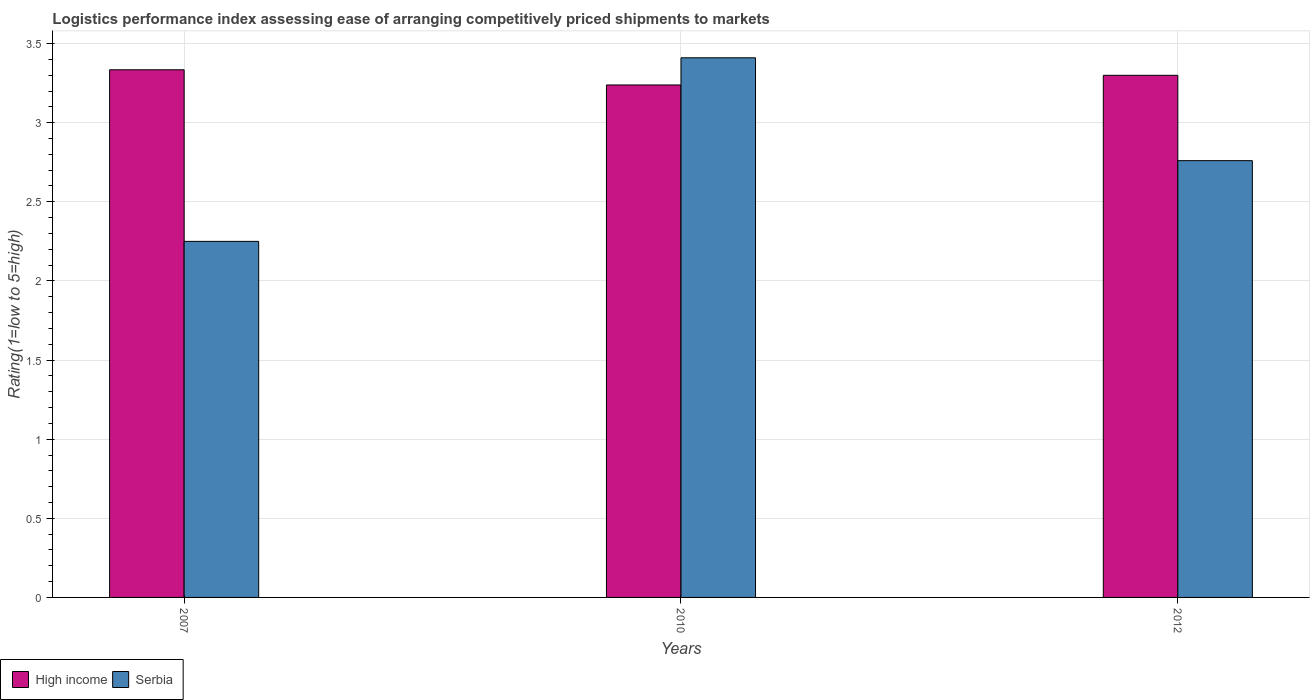How many different coloured bars are there?
Your response must be concise. 2. How many groups of bars are there?
Offer a terse response. 3. Are the number of bars on each tick of the X-axis equal?
Provide a short and direct response. Yes. What is the label of the 2nd group of bars from the left?
Your response must be concise. 2010. In how many cases, is the number of bars for a given year not equal to the number of legend labels?
Provide a short and direct response. 0. What is the Logistic performance index in Serbia in 2012?
Keep it short and to the point. 2.76. Across all years, what is the maximum Logistic performance index in Serbia?
Provide a succinct answer. 3.41. Across all years, what is the minimum Logistic performance index in High income?
Ensure brevity in your answer.  3.24. In which year was the Logistic performance index in High income maximum?
Your answer should be very brief. 2007. What is the total Logistic performance index in Serbia in the graph?
Ensure brevity in your answer.  8.42. What is the difference between the Logistic performance index in Serbia in 2007 and that in 2012?
Give a very brief answer. -0.51. What is the difference between the Logistic performance index in Serbia in 2007 and the Logistic performance index in High income in 2010?
Make the answer very short. -0.99. What is the average Logistic performance index in High income per year?
Provide a succinct answer. 3.29. In the year 2012, what is the difference between the Logistic performance index in Serbia and Logistic performance index in High income?
Provide a succinct answer. -0.54. In how many years, is the Logistic performance index in High income greater than 1?
Make the answer very short. 3. What is the ratio of the Logistic performance index in High income in 2007 to that in 2012?
Make the answer very short. 1.01. Is the Logistic performance index in Serbia in 2007 less than that in 2010?
Offer a terse response. Yes. Is the difference between the Logistic performance index in Serbia in 2007 and 2012 greater than the difference between the Logistic performance index in High income in 2007 and 2012?
Provide a succinct answer. No. What is the difference between the highest and the second highest Logistic performance index in Serbia?
Your response must be concise. 0.65. What is the difference between the highest and the lowest Logistic performance index in High income?
Give a very brief answer. 0.1. What does the 2nd bar from the right in 2012 represents?
Ensure brevity in your answer.  High income. Are the values on the major ticks of Y-axis written in scientific E-notation?
Offer a terse response. No. Where does the legend appear in the graph?
Offer a terse response. Bottom left. How many legend labels are there?
Offer a very short reply. 2. How are the legend labels stacked?
Offer a terse response. Horizontal. What is the title of the graph?
Your answer should be compact. Logistics performance index assessing ease of arranging competitively priced shipments to markets. What is the label or title of the X-axis?
Offer a very short reply. Years. What is the label or title of the Y-axis?
Make the answer very short. Rating(1=low to 5=high). What is the Rating(1=low to 5=high) in High income in 2007?
Give a very brief answer. 3.33. What is the Rating(1=low to 5=high) of Serbia in 2007?
Your response must be concise. 2.25. What is the Rating(1=low to 5=high) of High income in 2010?
Offer a terse response. 3.24. What is the Rating(1=low to 5=high) in Serbia in 2010?
Provide a short and direct response. 3.41. What is the Rating(1=low to 5=high) in High income in 2012?
Your answer should be compact. 3.3. What is the Rating(1=low to 5=high) of Serbia in 2012?
Make the answer very short. 2.76. Across all years, what is the maximum Rating(1=low to 5=high) of High income?
Your response must be concise. 3.33. Across all years, what is the maximum Rating(1=low to 5=high) in Serbia?
Ensure brevity in your answer.  3.41. Across all years, what is the minimum Rating(1=low to 5=high) of High income?
Give a very brief answer. 3.24. Across all years, what is the minimum Rating(1=low to 5=high) of Serbia?
Your answer should be very brief. 2.25. What is the total Rating(1=low to 5=high) of High income in the graph?
Provide a short and direct response. 9.87. What is the total Rating(1=low to 5=high) of Serbia in the graph?
Offer a very short reply. 8.42. What is the difference between the Rating(1=low to 5=high) in High income in 2007 and that in 2010?
Offer a very short reply. 0.1. What is the difference between the Rating(1=low to 5=high) in Serbia in 2007 and that in 2010?
Offer a terse response. -1.16. What is the difference between the Rating(1=low to 5=high) of High income in 2007 and that in 2012?
Make the answer very short. 0.04. What is the difference between the Rating(1=low to 5=high) in Serbia in 2007 and that in 2012?
Make the answer very short. -0.51. What is the difference between the Rating(1=low to 5=high) in High income in 2010 and that in 2012?
Offer a terse response. -0.06. What is the difference between the Rating(1=low to 5=high) of Serbia in 2010 and that in 2012?
Give a very brief answer. 0.65. What is the difference between the Rating(1=low to 5=high) in High income in 2007 and the Rating(1=low to 5=high) in Serbia in 2010?
Provide a succinct answer. -0.08. What is the difference between the Rating(1=low to 5=high) of High income in 2007 and the Rating(1=low to 5=high) of Serbia in 2012?
Your answer should be very brief. 0.57. What is the difference between the Rating(1=low to 5=high) of High income in 2010 and the Rating(1=low to 5=high) of Serbia in 2012?
Offer a terse response. 0.48. What is the average Rating(1=low to 5=high) in High income per year?
Provide a short and direct response. 3.29. What is the average Rating(1=low to 5=high) of Serbia per year?
Give a very brief answer. 2.81. In the year 2007, what is the difference between the Rating(1=low to 5=high) in High income and Rating(1=low to 5=high) in Serbia?
Provide a succinct answer. 1.08. In the year 2010, what is the difference between the Rating(1=low to 5=high) of High income and Rating(1=low to 5=high) of Serbia?
Your answer should be very brief. -0.17. In the year 2012, what is the difference between the Rating(1=low to 5=high) in High income and Rating(1=low to 5=high) in Serbia?
Offer a very short reply. 0.54. What is the ratio of the Rating(1=low to 5=high) of High income in 2007 to that in 2010?
Keep it short and to the point. 1.03. What is the ratio of the Rating(1=low to 5=high) in Serbia in 2007 to that in 2010?
Offer a very short reply. 0.66. What is the ratio of the Rating(1=low to 5=high) of High income in 2007 to that in 2012?
Give a very brief answer. 1.01. What is the ratio of the Rating(1=low to 5=high) of Serbia in 2007 to that in 2012?
Give a very brief answer. 0.82. What is the ratio of the Rating(1=low to 5=high) of High income in 2010 to that in 2012?
Keep it short and to the point. 0.98. What is the ratio of the Rating(1=low to 5=high) of Serbia in 2010 to that in 2012?
Keep it short and to the point. 1.24. What is the difference between the highest and the second highest Rating(1=low to 5=high) of High income?
Provide a short and direct response. 0.04. What is the difference between the highest and the second highest Rating(1=low to 5=high) of Serbia?
Ensure brevity in your answer.  0.65. What is the difference between the highest and the lowest Rating(1=low to 5=high) in High income?
Your answer should be compact. 0.1. What is the difference between the highest and the lowest Rating(1=low to 5=high) in Serbia?
Keep it short and to the point. 1.16. 